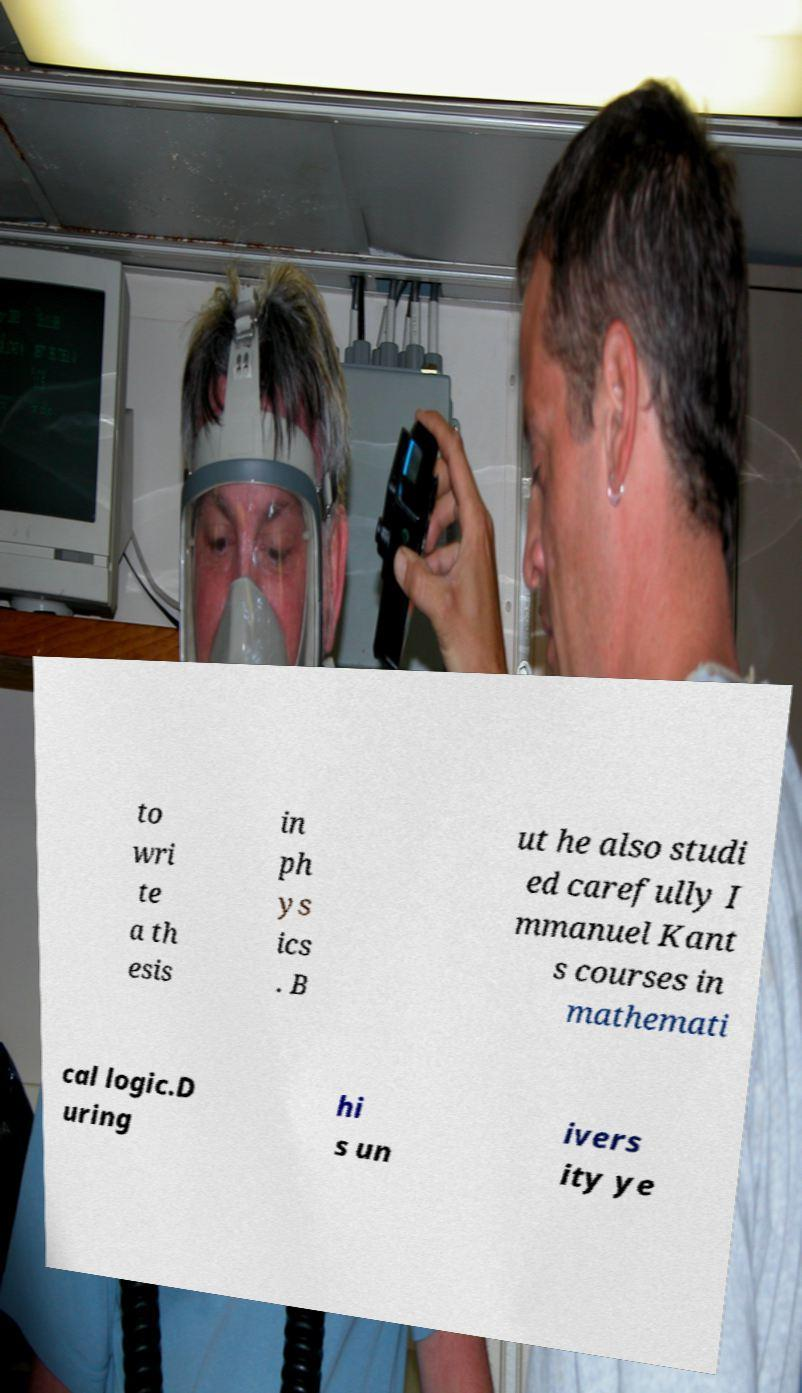Can you read and provide the text displayed in the image?This photo seems to have some interesting text. Can you extract and type it out for me? to wri te a th esis in ph ys ics . B ut he also studi ed carefully I mmanuel Kant s courses in mathemati cal logic.D uring hi s un ivers ity ye 